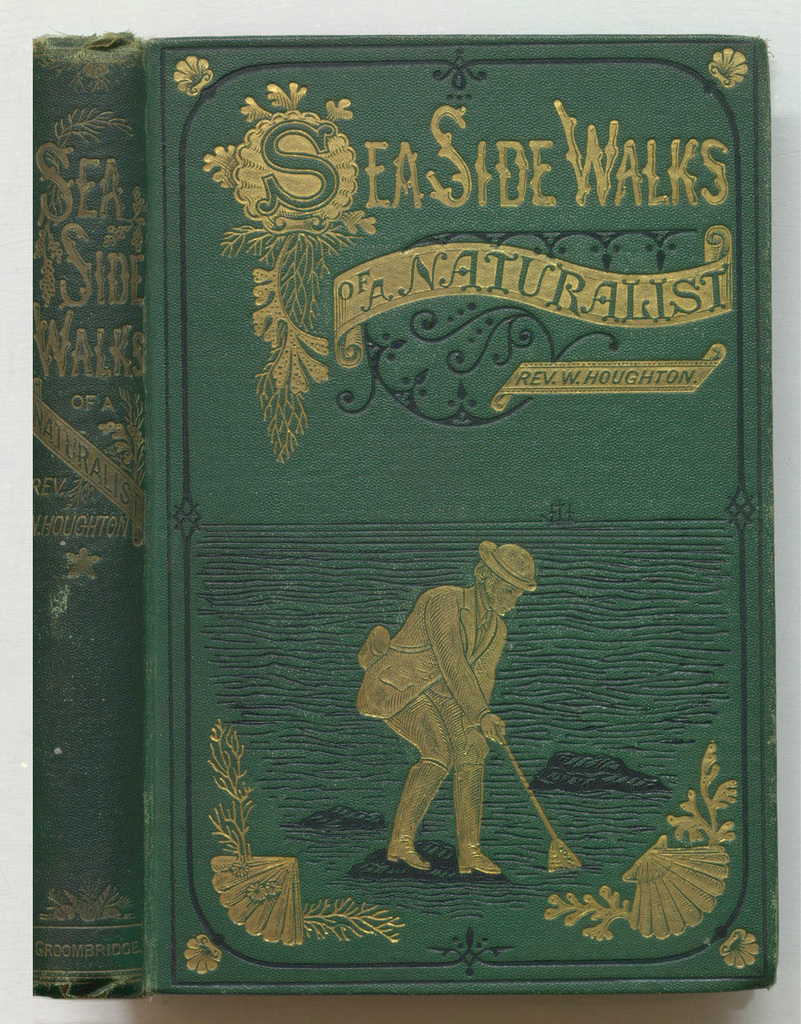What might be the significance of the detailed ornamental design around the book title? The ornate designs around the book title, including seaweeds and sea creatures, likely serve to attract readers with visual elements that underline the book's focus on marine life and the lushness of nature, enhancing the thematic appeal of the text. 